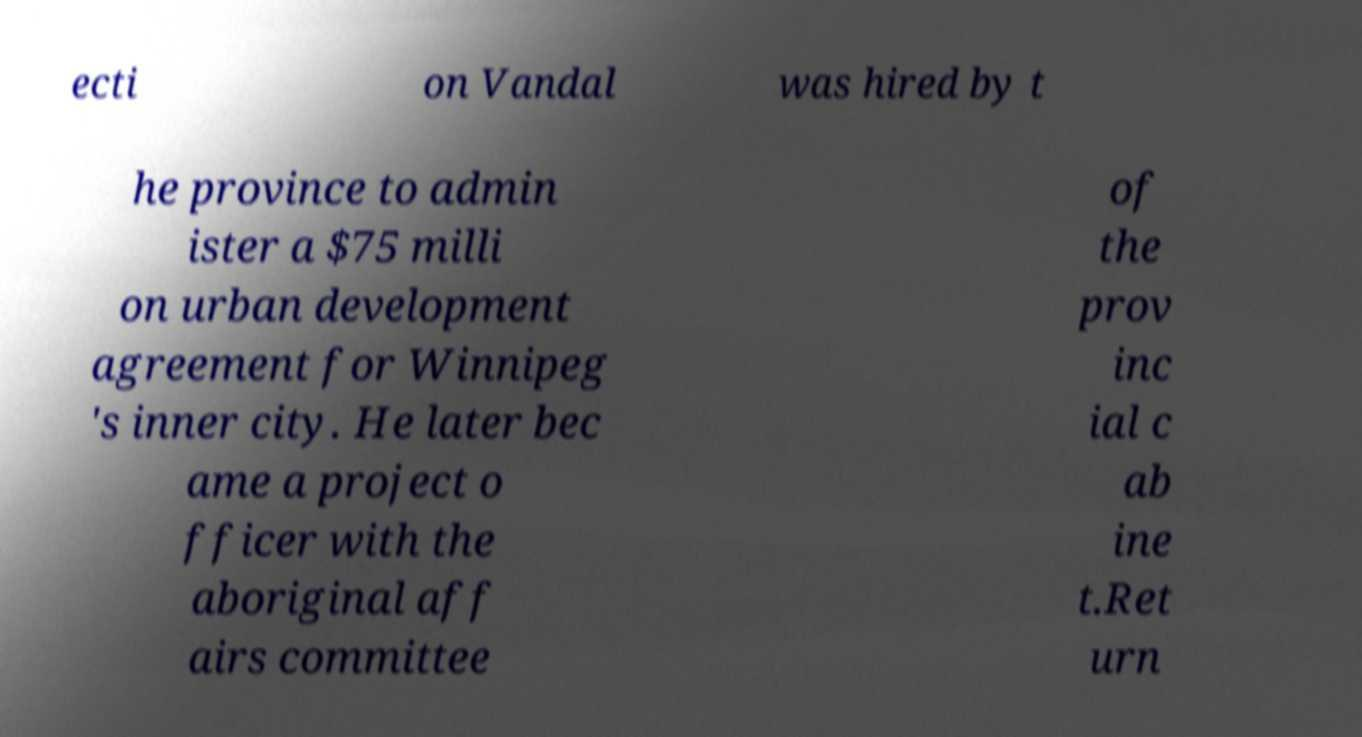Could you assist in decoding the text presented in this image and type it out clearly? ecti on Vandal was hired by t he province to admin ister a $75 milli on urban development agreement for Winnipeg 's inner city. He later bec ame a project o fficer with the aboriginal aff airs committee of the prov inc ial c ab ine t.Ret urn 